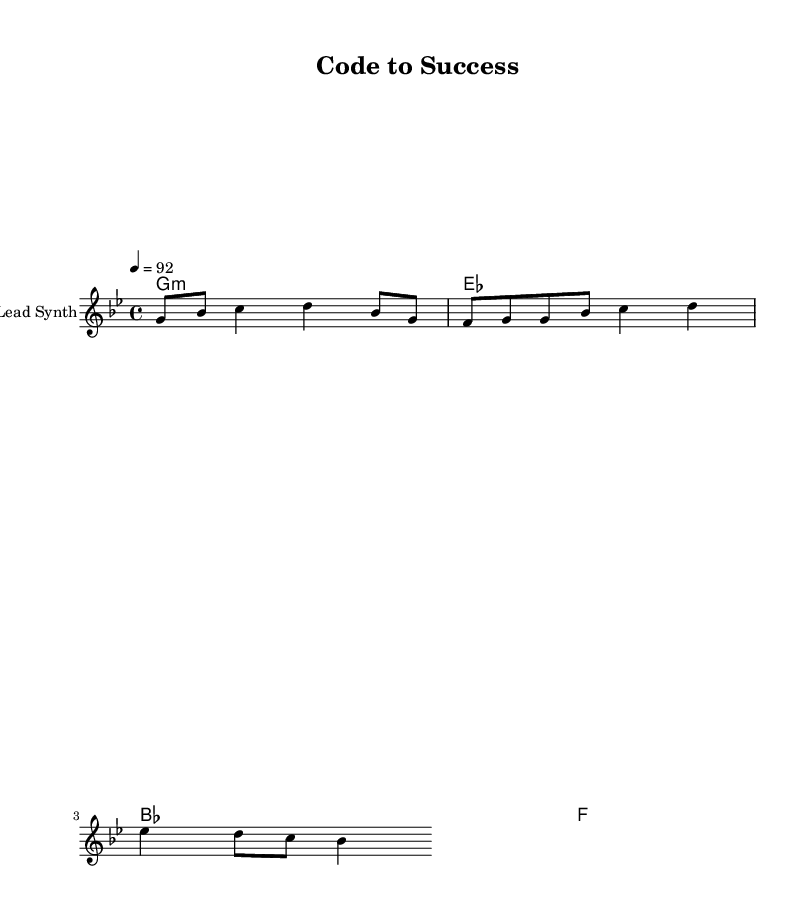What is the key signature of this music? The key signature is indicated by the sharp or flat symbols preceding the notes. Here, it shows one flat, thus it is G minor.
Answer: G minor What is the time signature of this music? The time signature is shown at the beginning of the piece as 4/4, indicating four beats per measure with a quarter note receiving one beat.
Answer: 4/4 What is the tempo marking of this piece? The tempo marking is found in the first section of the score where it specifies the speed. Here, it indicates a tempo of 92 beats per minute.
Answer: 92 How many measures are there in the melody section? By counting the hypermetric bars in the melody line, we observe there are four measures present in the excerpt.
Answer: Four What type of music is this piece classified as? The lyrics and overall structure suggest it's a motivational hip-hop track, utilizing modern language and themes of tech disruption.
Answer: Motivational hip-hop How many chord changes are represented in the score? By examining the chord section, there are four distinct chord symbols provided, indicating each chord change that corresponds with the melody.
Answer: Four What is the first lyric line of this music? By looking closely at the lyrics section, the first lyric line is shown as "Coding through the night, chasing that I P O dream." This sets the theme for the song.
Answer: Coding through the night, chasing that I P O dream 